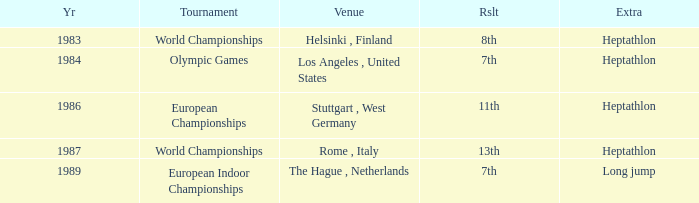Where was the 1984 Olympics hosted? Olympic Games. 